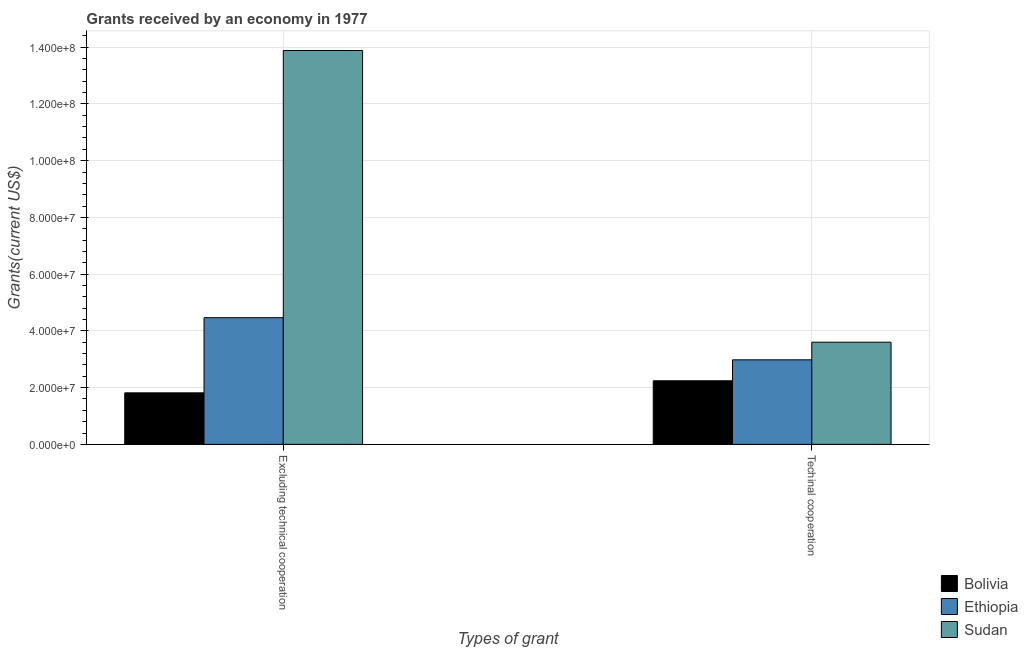How many different coloured bars are there?
Keep it short and to the point. 3. Are the number of bars per tick equal to the number of legend labels?
Give a very brief answer. Yes. Are the number of bars on each tick of the X-axis equal?
Your response must be concise. Yes. What is the label of the 2nd group of bars from the left?
Offer a terse response. Techinal cooperation. What is the amount of grants received(including technical cooperation) in Sudan?
Your answer should be compact. 3.60e+07. Across all countries, what is the maximum amount of grants received(including technical cooperation)?
Provide a succinct answer. 3.60e+07. Across all countries, what is the minimum amount of grants received(including technical cooperation)?
Give a very brief answer. 2.24e+07. In which country was the amount of grants received(including technical cooperation) maximum?
Your response must be concise. Sudan. What is the total amount of grants received(excluding technical cooperation) in the graph?
Offer a terse response. 2.02e+08. What is the difference between the amount of grants received(including technical cooperation) in Ethiopia and that in Bolivia?
Your response must be concise. 7.39e+06. What is the difference between the amount of grants received(including technical cooperation) in Bolivia and the amount of grants received(excluding technical cooperation) in Ethiopia?
Provide a succinct answer. -2.22e+07. What is the average amount of grants received(excluding technical cooperation) per country?
Make the answer very short. 6.72e+07. What is the difference between the amount of grants received(excluding technical cooperation) and amount of grants received(including technical cooperation) in Bolivia?
Offer a very short reply. -4.25e+06. What is the ratio of the amount of grants received(including technical cooperation) in Sudan to that in Bolivia?
Offer a very short reply. 1.61. Is the amount of grants received(including technical cooperation) in Sudan less than that in Ethiopia?
Provide a succinct answer. No. What does the 2nd bar from the left in Techinal cooperation represents?
Keep it short and to the point. Ethiopia. What does the 1st bar from the right in Excluding technical cooperation represents?
Your response must be concise. Sudan. How many bars are there?
Make the answer very short. 6. Are all the bars in the graph horizontal?
Offer a very short reply. No. What is the difference between two consecutive major ticks on the Y-axis?
Your answer should be very brief. 2.00e+07. Are the values on the major ticks of Y-axis written in scientific E-notation?
Provide a short and direct response. Yes. Does the graph contain any zero values?
Your response must be concise. No. Does the graph contain grids?
Keep it short and to the point. Yes. How are the legend labels stacked?
Provide a short and direct response. Vertical. What is the title of the graph?
Ensure brevity in your answer.  Grants received by an economy in 1977. Does "Antigua and Barbuda" appear as one of the legend labels in the graph?
Provide a short and direct response. No. What is the label or title of the X-axis?
Offer a very short reply. Types of grant. What is the label or title of the Y-axis?
Make the answer very short. Grants(current US$). What is the Grants(current US$) in Bolivia in Excluding technical cooperation?
Provide a succinct answer. 1.82e+07. What is the Grants(current US$) of Ethiopia in Excluding technical cooperation?
Offer a terse response. 4.46e+07. What is the Grants(current US$) in Sudan in Excluding technical cooperation?
Provide a succinct answer. 1.39e+08. What is the Grants(current US$) in Bolivia in Techinal cooperation?
Your response must be concise. 2.24e+07. What is the Grants(current US$) of Ethiopia in Techinal cooperation?
Ensure brevity in your answer.  2.98e+07. What is the Grants(current US$) in Sudan in Techinal cooperation?
Your answer should be very brief. 3.60e+07. Across all Types of grant, what is the maximum Grants(current US$) in Bolivia?
Your answer should be very brief. 2.24e+07. Across all Types of grant, what is the maximum Grants(current US$) of Ethiopia?
Make the answer very short. 4.46e+07. Across all Types of grant, what is the maximum Grants(current US$) of Sudan?
Offer a very short reply. 1.39e+08. Across all Types of grant, what is the minimum Grants(current US$) in Bolivia?
Keep it short and to the point. 1.82e+07. Across all Types of grant, what is the minimum Grants(current US$) of Ethiopia?
Offer a terse response. 2.98e+07. Across all Types of grant, what is the minimum Grants(current US$) of Sudan?
Offer a terse response. 3.60e+07. What is the total Grants(current US$) of Bolivia in the graph?
Your answer should be compact. 4.06e+07. What is the total Grants(current US$) in Ethiopia in the graph?
Your answer should be compact. 7.44e+07. What is the total Grants(current US$) of Sudan in the graph?
Offer a very short reply. 1.75e+08. What is the difference between the Grants(current US$) in Bolivia in Excluding technical cooperation and that in Techinal cooperation?
Provide a short and direct response. -4.25e+06. What is the difference between the Grants(current US$) in Ethiopia in Excluding technical cooperation and that in Techinal cooperation?
Offer a terse response. 1.48e+07. What is the difference between the Grants(current US$) of Sudan in Excluding technical cooperation and that in Techinal cooperation?
Offer a terse response. 1.03e+08. What is the difference between the Grants(current US$) of Bolivia in Excluding technical cooperation and the Grants(current US$) of Ethiopia in Techinal cooperation?
Your response must be concise. -1.16e+07. What is the difference between the Grants(current US$) of Bolivia in Excluding technical cooperation and the Grants(current US$) of Sudan in Techinal cooperation?
Ensure brevity in your answer.  -1.78e+07. What is the difference between the Grants(current US$) of Ethiopia in Excluding technical cooperation and the Grants(current US$) of Sudan in Techinal cooperation?
Your answer should be compact. 8.64e+06. What is the average Grants(current US$) of Bolivia per Types of grant?
Give a very brief answer. 2.03e+07. What is the average Grants(current US$) of Ethiopia per Types of grant?
Ensure brevity in your answer.  3.72e+07. What is the average Grants(current US$) of Sudan per Types of grant?
Your answer should be very brief. 8.74e+07. What is the difference between the Grants(current US$) of Bolivia and Grants(current US$) of Ethiopia in Excluding technical cooperation?
Your answer should be compact. -2.65e+07. What is the difference between the Grants(current US$) of Bolivia and Grants(current US$) of Sudan in Excluding technical cooperation?
Your answer should be very brief. -1.21e+08. What is the difference between the Grants(current US$) in Ethiopia and Grants(current US$) in Sudan in Excluding technical cooperation?
Make the answer very short. -9.42e+07. What is the difference between the Grants(current US$) of Bolivia and Grants(current US$) of Ethiopia in Techinal cooperation?
Offer a terse response. -7.39e+06. What is the difference between the Grants(current US$) in Bolivia and Grants(current US$) in Sudan in Techinal cooperation?
Provide a short and direct response. -1.36e+07. What is the difference between the Grants(current US$) in Ethiopia and Grants(current US$) in Sudan in Techinal cooperation?
Offer a very short reply. -6.21e+06. What is the ratio of the Grants(current US$) of Bolivia in Excluding technical cooperation to that in Techinal cooperation?
Your answer should be compact. 0.81. What is the ratio of the Grants(current US$) in Ethiopia in Excluding technical cooperation to that in Techinal cooperation?
Give a very brief answer. 1.5. What is the ratio of the Grants(current US$) in Sudan in Excluding technical cooperation to that in Techinal cooperation?
Your answer should be very brief. 3.86. What is the difference between the highest and the second highest Grants(current US$) of Bolivia?
Offer a very short reply. 4.25e+06. What is the difference between the highest and the second highest Grants(current US$) in Ethiopia?
Your answer should be very brief. 1.48e+07. What is the difference between the highest and the second highest Grants(current US$) of Sudan?
Keep it short and to the point. 1.03e+08. What is the difference between the highest and the lowest Grants(current US$) in Bolivia?
Your answer should be very brief. 4.25e+06. What is the difference between the highest and the lowest Grants(current US$) of Ethiopia?
Your answer should be very brief. 1.48e+07. What is the difference between the highest and the lowest Grants(current US$) of Sudan?
Provide a succinct answer. 1.03e+08. 